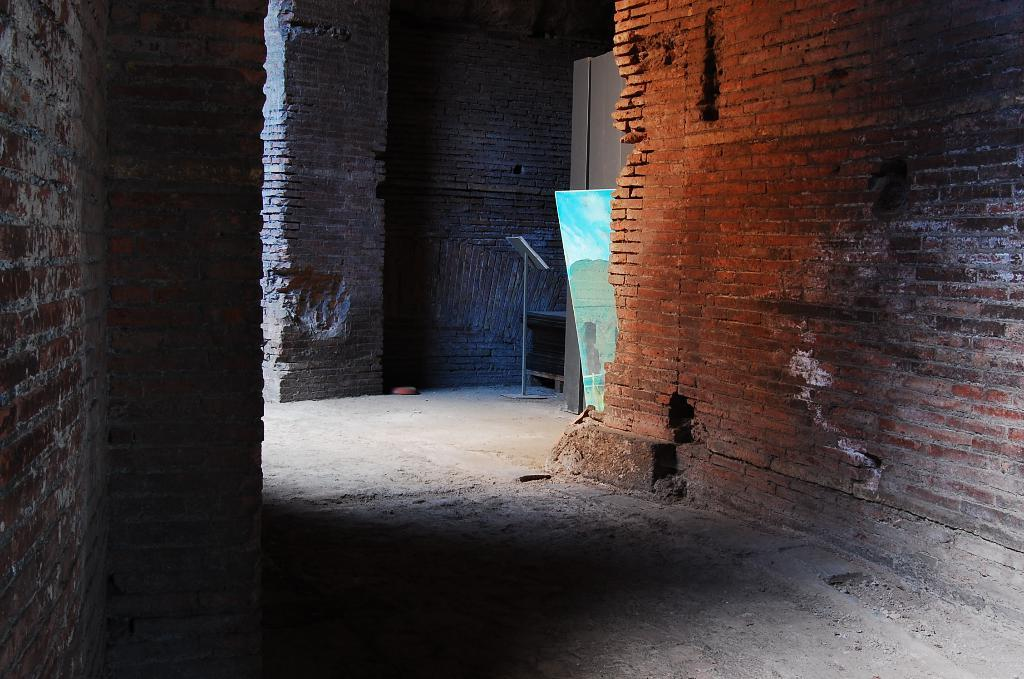Where was the image taken? The image was taken indoors. What is located in the middle of the image? There is a stand and a board in the middle of the image. What type of fish can be seen swimming on the board in the image? There are no fish present in the image; it features a stand and a board. 